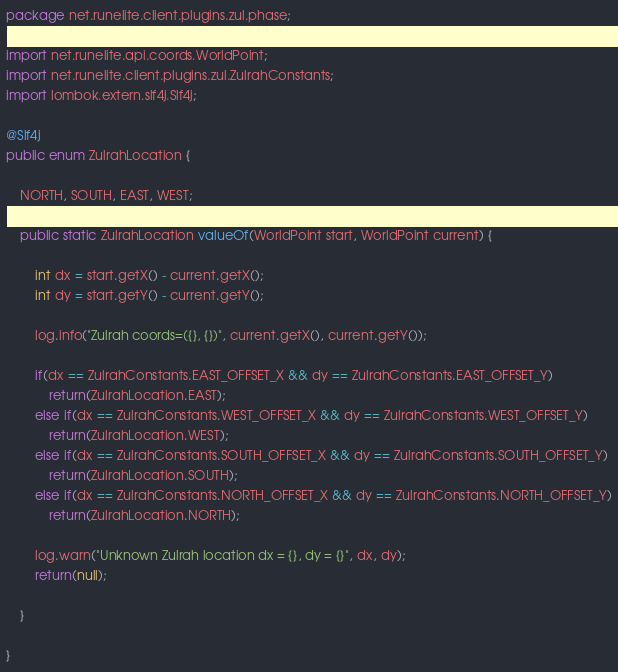<code> <loc_0><loc_0><loc_500><loc_500><_Java_>package net.runelite.client.plugins.zul.phase;

import net.runelite.api.coords.WorldPoint;
import net.runelite.client.plugins.zul.ZulrahConstants;
import lombok.extern.slf4j.Slf4j;

@Slf4j
public enum ZulrahLocation {

    NORTH, SOUTH, EAST, WEST;

    public static ZulrahLocation valueOf(WorldPoint start, WorldPoint current) {

        int dx = start.getX() - current.getX();
        int dy = start.getY() - current.getY();

        log.info("Zulrah coords=({}, {})", current.getX(), current.getY());

        if(dx == ZulrahConstants.EAST_OFFSET_X && dy == ZulrahConstants.EAST_OFFSET_Y)
            return(ZulrahLocation.EAST);
        else if(dx == ZulrahConstants.WEST_OFFSET_X && dy == ZulrahConstants.WEST_OFFSET_Y)
            return(ZulrahLocation.WEST);
        else if(dx == ZulrahConstants.SOUTH_OFFSET_X && dy == ZulrahConstants.SOUTH_OFFSET_Y)
            return(ZulrahLocation.SOUTH);
        else if(dx == ZulrahConstants.NORTH_OFFSET_X && dy == ZulrahConstants.NORTH_OFFSET_Y)
            return(ZulrahLocation.NORTH);
            
        log.warn("Unknown Zulrah location dx = {}, dy = {}", dx, dy);
        return(null);
    
    }

}</code> 